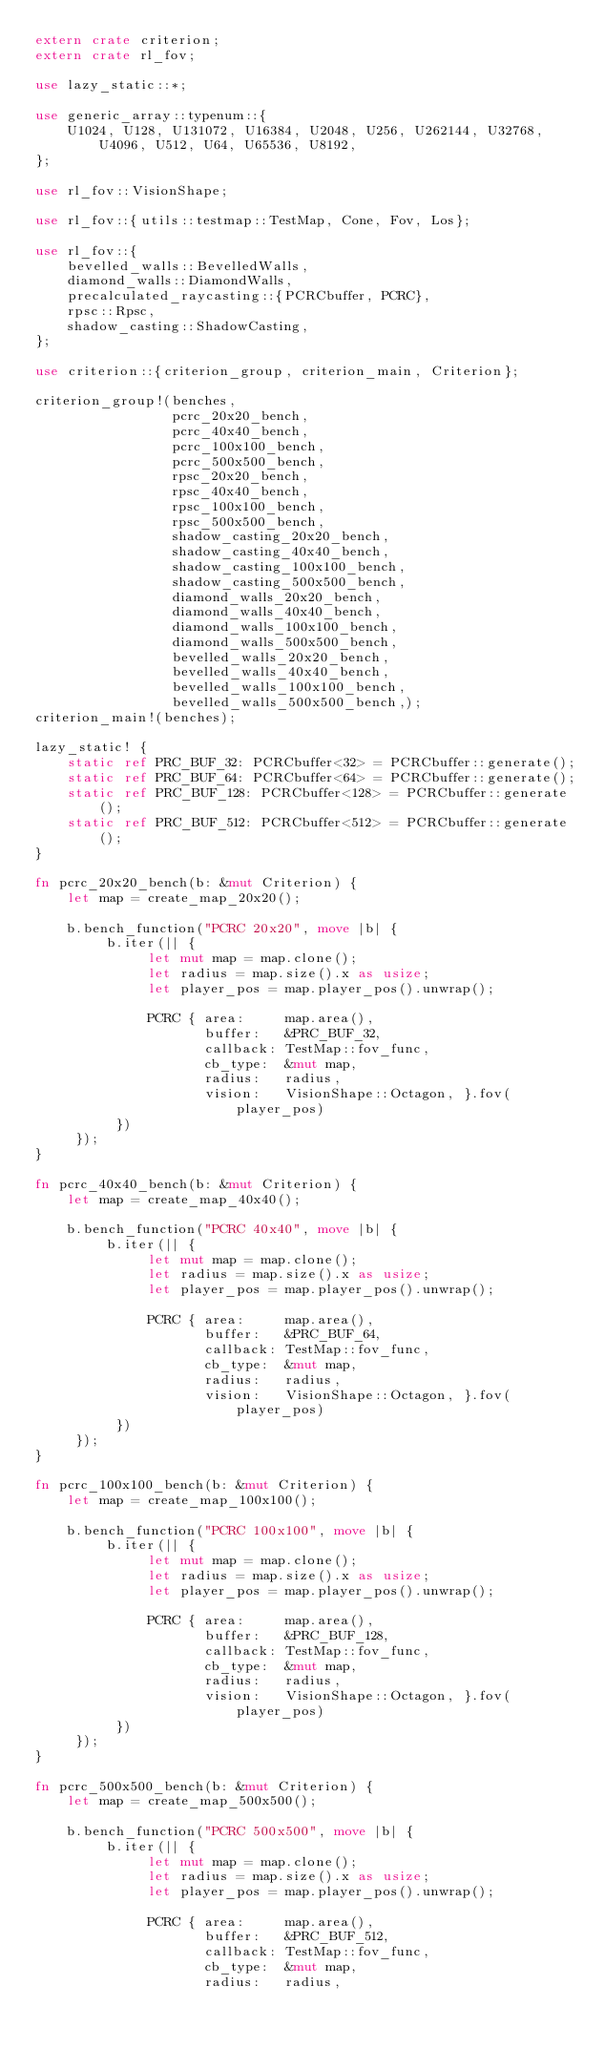<code> <loc_0><loc_0><loc_500><loc_500><_Rust_>extern crate criterion;
extern crate rl_fov;

use lazy_static::*;

use generic_array::typenum::{
    U1024, U128, U131072, U16384, U2048, U256, U262144, U32768, U4096, U512, U64, U65536, U8192,
};

use rl_fov::VisionShape;

use rl_fov::{utils::testmap::TestMap, Cone, Fov, Los};

use rl_fov::{
    bevelled_walls::BevelledWalls,
    diamond_walls::DiamondWalls,
    precalculated_raycasting::{PCRCbuffer, PCRC},
    rpsc::Rpsc,
    shadow_casting::ShadowCasting,
};

use criterion::{criterion_group, criterion_main, Criterion};

criterion_group!(benches,
                 pcrc_20x20_bench,
                 pcrc_40x40_bench,
                 pcrc_100x100_bench,
                 pcrc_500x500_bench,
                 rpsc_20x20_bench,
                 rpsc_40x40_bench,
                 rpsc_100x100_bench,
                 rpsc_500x500_bench,
                 shadow_casting_20x20_bench,
                 shadow_casting_40x40_bench,
                 shadow_casting_100x100_bench,
                 shadow_casting_500x500_bench,
                 diamond_walls_20x20_bench,
                 diamond_walls_40x40_bench,
                 diamond_walls_100x100_bench,
                 diamond_walls_500x500_bench,
                 bevelled_walls_20x20_bench,
                 bevelled_walls_40x40_bench,
                 bevelled_walls_100x100_bench,
                 bevelled_walls_500x500_bench,);
criterion_main!(benches);

lazy_static! {
    static ref PRC_BUF_32: PCRCbuffer<32> = PCRCbuffer::generate();
    static ref PRC_BUF_64: PCRCbuffer<64> = PCRCbuffer::generate();
    static ref PRC_BUF_128: PCRCbuffer<128> = PCRCbuffer::generate();
    static ref PRC_BUF_512: PCRCbuffer<512> = PCRCbuffer::generate();
}

fn pcrc_20x20_bench(b: &mut Criterion) {
    let map = create_map_20x20();

    b.bench_function("PCRC 20x20", move |b| {
         b.iter(|| {
              let mut map = map.clone();
              let radius = map.size().x as usize;
              let player_pos = map.player_pos().unwrap();

              PCRC { area:     map.area(),
                     buffer:   &PRC_BUF_32,
                     callback: TestMap::fov_func,
                     cb_type:  &mut map,
                     radius:   radius,
                     vision:   VisionShape::Octagon, }.fov(player_pos)
          })
     });
}

fn pcrc_40x40_bench(b: &mut Criterion) {
    let map = create_map_40x40();

    b.bench_function("PCRC 40x40", move |b| {
         b.iter(|| {
              let mut map = map.clone();
              let radius = map.size().x as usize;
              let player_pos = map.player_pos().unwrap();

              PCRC { area:     map.area(),
                     buffer:   &PRC_BUF_64,
                     callback: TestMap::fov_func,
                     cb_type:  &mut map,
                     radius:   radius,
                     vision:   VisionShape::Octagon, }.fov(player_pos)
          })
     });
}

fn pcrc_100x100_bench(b: &mut Criterion) {
    let map = create_map_100x100();

    b.bench_function("PCRC 100x100", move |b| {
         b.iter(|| {
              let mut map = map.clone();
              let radius = map.size().x as usize;
              let player_pos = map.player_pos().unwrap();

              PCRC { area:     map.area(),
                     buffer:   &PRC_BUF_128,
                     callback: TestMap::fov_func,
                     cb_type:  &mut map,
                     radius:   radius,
                     vision:   VisionShape::Octagon, }.fov(player_pos)
          })
     });
}

fn pcrc_500x500_bench(b: &mut Criterion) {
    let map = create_map_500x500();

    b.bench_function("PCRC 500x500", move |b| {
         b.iter(|| {
              let mut map = map.clone();
              let radius = map.size().x as usize;
              let player_pos = map.player_pos().unwrap();

              PCRC { area:     map.area(),
                     buffer:   &PRC_BUF_512,
                     callback: TestMap::fov_func,
                     cb_type:  &mut map,
                     radius:   radius,</code> 